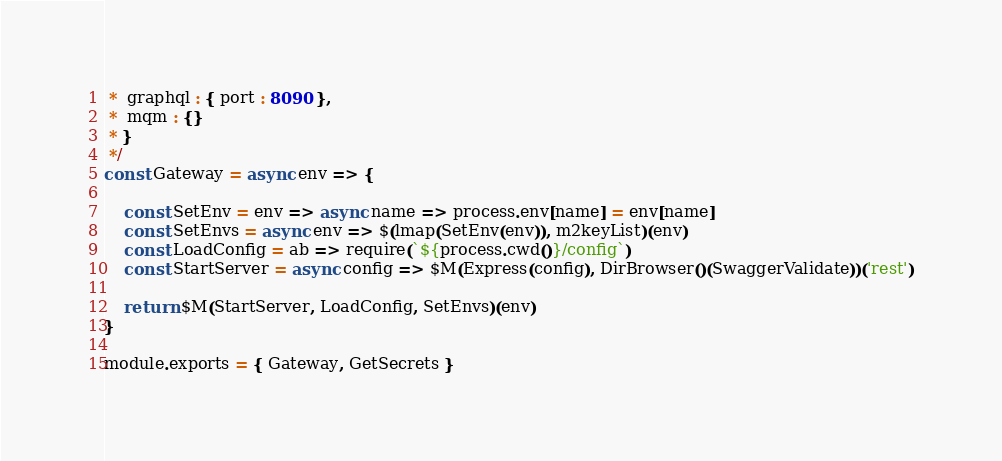<code> <loc_0><loc_0><loc_500><loc_500><_JavaScript_> *  graphql : { port : 8090 },
 *  mqm : {}
 * }
 */
const Gateway = async env => {

    const SetEnv = env => async name => process.env[name] = env[name]
    const SetEnvs = async env => $(lmap(SetEnv(env)), m2keyList)(env)
    const LoadConfig = ab => require(`${process.cwd()}/config`)
    const StartServer = async config => $M(Express(config), DirBrowser()(SwaggerValidate))('rest')

    return $M(StartServer, LoadConfig, SetEnvs)(env)
}

module.exports = { Gateway, GetSecrets }





</code> 